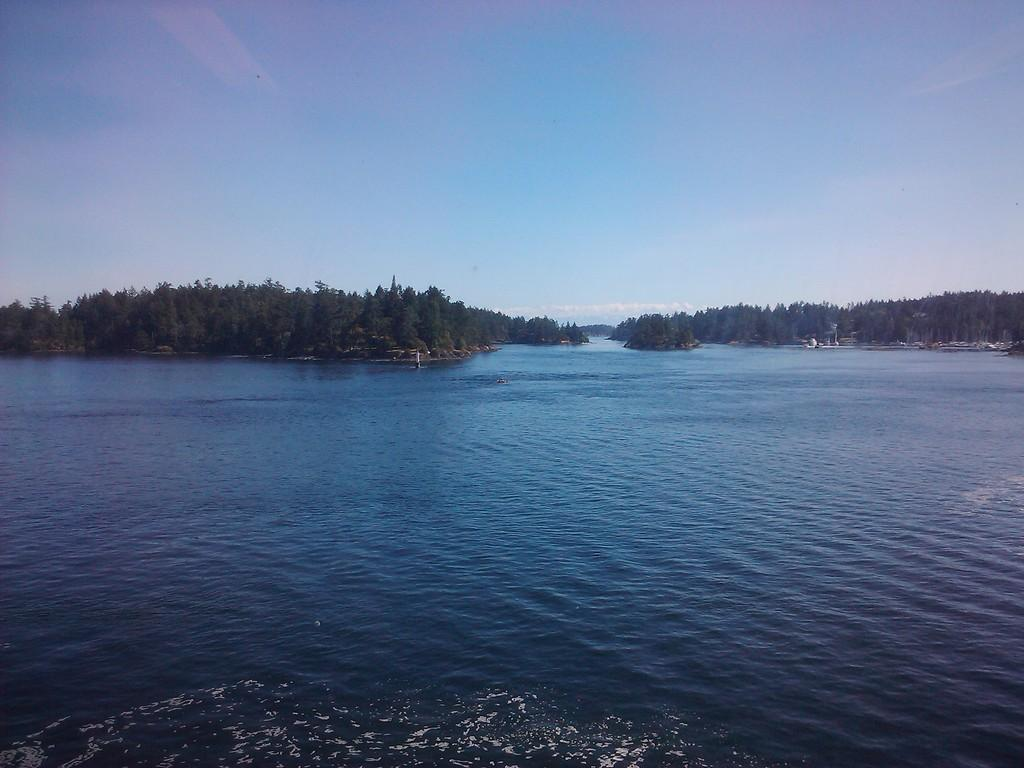What type of natural feature is present in the image? There is a river in the image. What other natural elements can be seen in the image? There are trees in the image. What is visible in the background of the image? The sky is visible in the image. What can be observed in the sky? Clouds are present in the sky. Where is the beggar standing in the image? There is no beggar present in the image. What type of gardening tool can be seen in the image? There is no gardening tool, such as a rake, present in the image. 